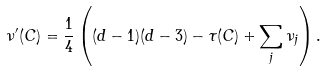Convert formula to latex. <formula><loc_0><loc_0><loc_500><loc_500>\nu ^ { \prime } ( C ) = \frac { 1 } { 4 } \left ( ( d - 1 ) ( d - 3 ) - \tau ( C ) + \sum _ { j } \nu _ { j } \right ) .</formula> 